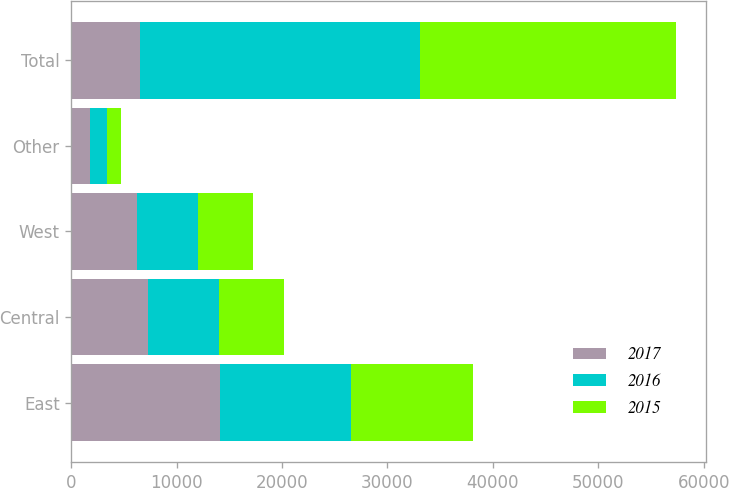Convert chart. <chart><loc_0><loc_0><loc_500><loc_500><stacked_bar_chart><ecel><fcel>East<fcel>Central<fcel>West<fcel>Other<fcel>Total<nl><fcel>2017<fcel>14076<fcel>7262<fcel>6238<fcel>1818<fcel>6513<nl><fcel>2016<fcel>12483<fcel>6788<fcel>5734<fcel>1558<fcel>26563<nl><fcel>2015<fcel>11515<fcel>6171<fcel>5245<fcel>1361<fcel>24292<nl></chart> 